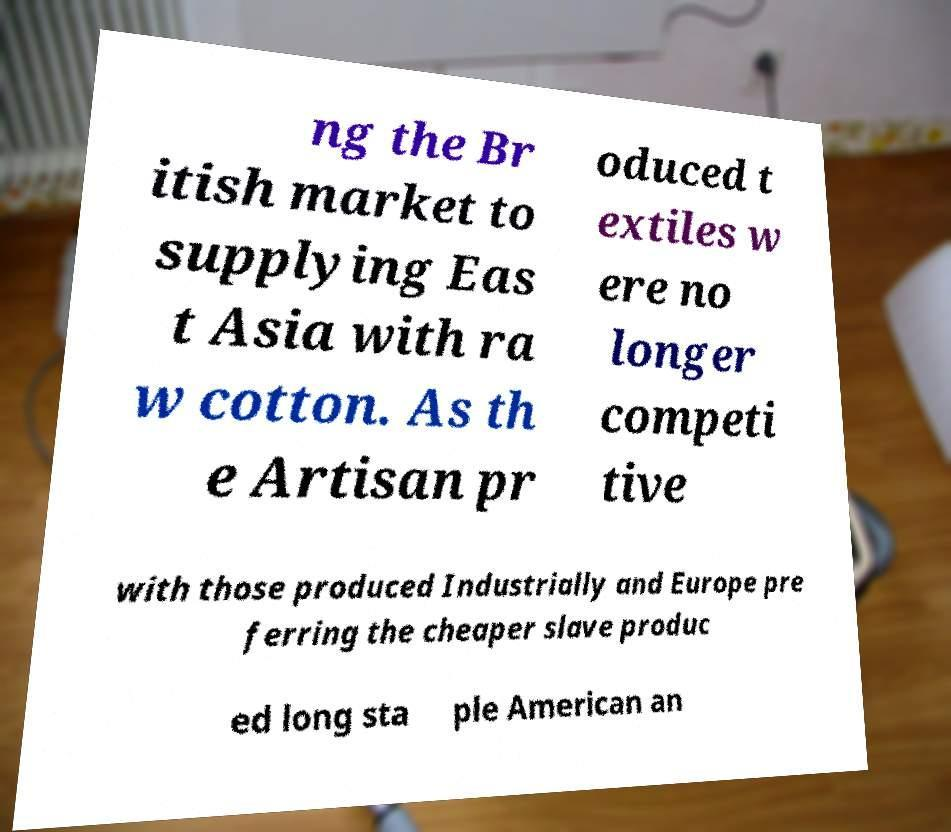Can you accurately transcribe the text from the provided image for me? ng the Br itish market to supplying Eas t Asia with ra w cotton. As th e Artisan pr oduced t extiles w ere no longer competi tive with those produced Industrially and Europe pre ferring the cheaper slave produc ed long sta ple American an 